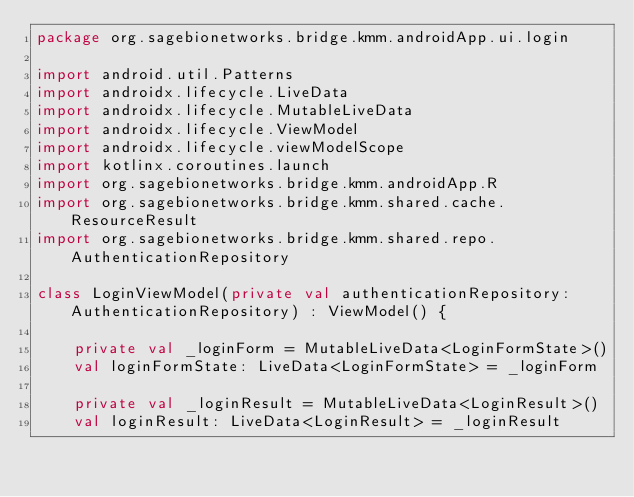<code> <loc_0><loc_0><loc_500><loc_500><_Kotlin_>package org.sagebionetworks.bridge.kmm.androidApp.ui.login

import android.util.Patterns
import androidx.lifecycle.LiveData
import androidx.lifecycle.MutableLiveData
import androidx.lifecycle.ViewModel
import androidx.lifecycle.viewModelScope
import kotlinx.coroutines.launch
import org.sagebionetworks.bridge.kmm.androidApp.R
import org.sagebionetworks.bridge.kmm.shared.cache.ResourceResult
import org.sagebionetworks.bridge.kmm.shared.repo.AuthenticationRepository

class LoginViewModel(private val authenticationRepository: AuthenticationRepository) : ViewModel() {

    private val _loginForm = MutableLiveData<LoginFormState>()
    val loginFormState: LiveData<LoginFormState> = _loginForm

    private val _loginResult = MutableLiveData<LoginResult>()
    val loginResult: LiveData<LoginResult> = _loginResult
</code> 